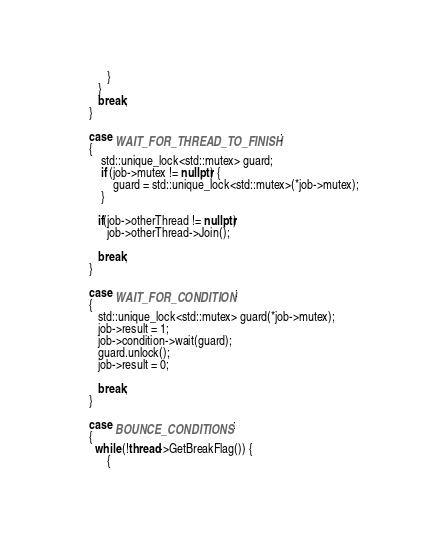Convert code to text. <code><loc_0><loc_0><loc_500><loc_500><_C++_>            }
         }
         break;
      }

      case WAIT_FOR_THREAD_TO_FINISH:
      {
          std::unique_lock<std::mutex> guard;
          if (job->mutex != nullptr) {
              guard = std::unique_lock<std::mutex>(*job->mutex);
          }

         if(job->otherThread != nullptr)
            job->otherThread->Join();

         break;
      }

      case WAIT_FOR_CONDITION:
      {
         std::unique_lock<std::mutex> guard(*job->mutex);
         job->result = 1;
         job->condition->wait(guard);
         guard.unlock();
         job->result = 0;

         break;
      }

      case BOUNCE_CONDITIONS:
      {
        while (!thread->GetBreakFlag()) {
            {</code> 